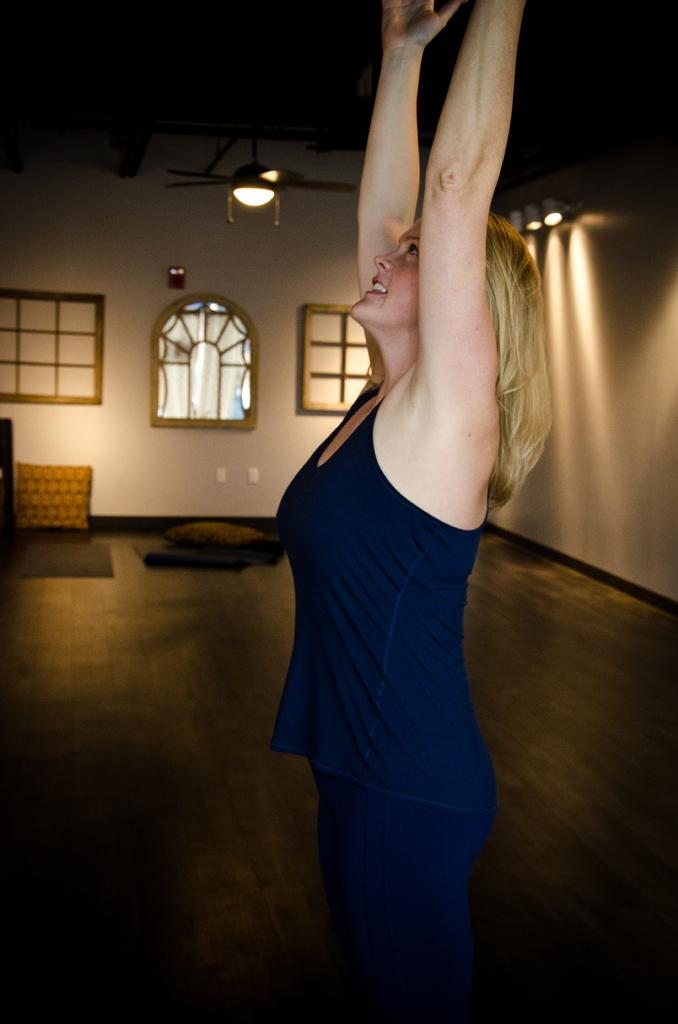Who is present in the image? There is a woman in the image. What is the woman doing in the image? The woman is standing. What is the woman wearing in the image? The woman is wearing a dark blue dress. What is behind the woman in the image? There is a wall behind the woman. What architectural features can be seen in the image? There are windows visible in the image. What soft furnishings are present in the image? There are pillows in the image. What type of coat is the woman wearing in the image? The woman is not wearing a coat in the image; she is wearing a dark blue dress. How much sugar is visible in the image? There is no sugar present in the image. 